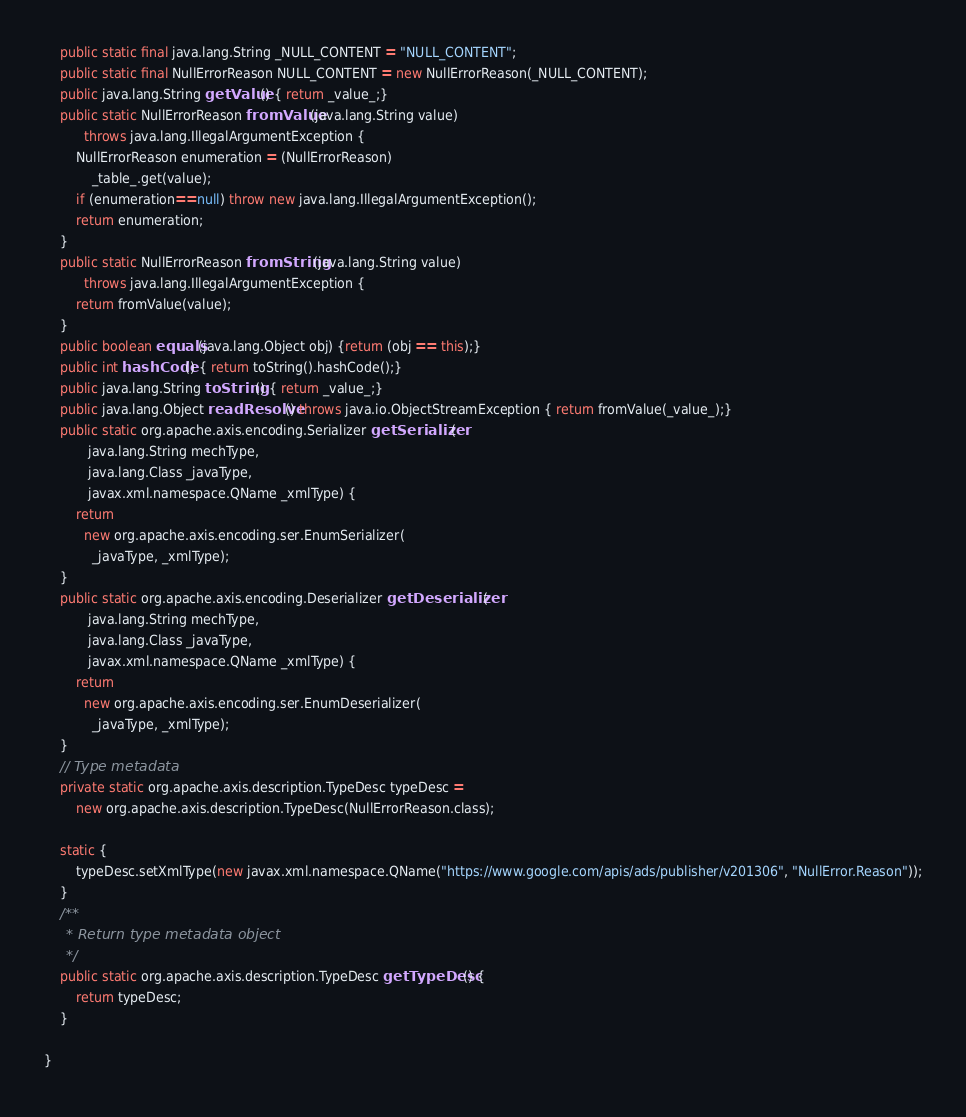Convert code to text. <code><loc_0><loc_0><loc_500><loc_500><_Java_>    public static final java.lang.String _NULL_CONTENT = "NULL_CONTENT";
    public static final NullErrorReason NULL_CONTENT = new NullErrorReason(_NULL_CONTENT);
    public java.lang.String getValue() { return _value_;}
    public static NullErrorReason fromValue(java.lang.String value)
          throws java.lang.IllegalArgumentException {
        NullErrorReason enumeration = (NullErrorReason)
            _table_.get(value);
        if (enumeration==null) throw new java.lang.IllegalArgumentException();
        return enumeration;
    }
    public static NullErrorReason fromString(java.lang.String value)
          throws java.lang.IllegalArgumentException {
        return fromValue(value);
    }
    public boolean equals(java.lang.Object obj) {return (obj == this);}
    public int hashCode() { return toString().hashCode();}
    public java.lang.String toString() { return _value_;}
    public java.lang.Object readResolve() throws java.io.ObjectStreamException { return fromValue(_value_);}
    public static org.apache.axis.encoding.Serializer getSerializer(
           java.lang.String mechType, 
           java.lang.Class _javaType,  
           javax.xml.namespace.QName _xmlType) {
        return 
          new org.apache.axis.encoding.ser.EnumSerializer(
            _javaType, _xmlType);
    }
    public static org.apache.axis.encoding.Deserializer getDeserializer(
           java.lang.String mechType, 
           java.lang.Class _javaType,  
           javax.xml.namespace.QName _xmlType) {
        return 
          new org.apache.axis.encoding.ser.EnumDeserializer(
            _javaType, _xmlType);
    }
    // Type metadata
    private static org.apache.axis.description.TypeDesc typeDesc =
        new org.apache.axis.description.TypeDesc(NullErrorReason.class);

    static {
        typeDesc.setXmlType(new javax.xml.namespace.QName("https://www.google.com/apis/ads/publisher/v201306", "NullError.Reason"));
    }
    /**
     * Return type metadata object
     */
    public static org.apache.axis.description.TypeDesc getTypeDesc() {
        return typeDesc;
    }

}
</code> 